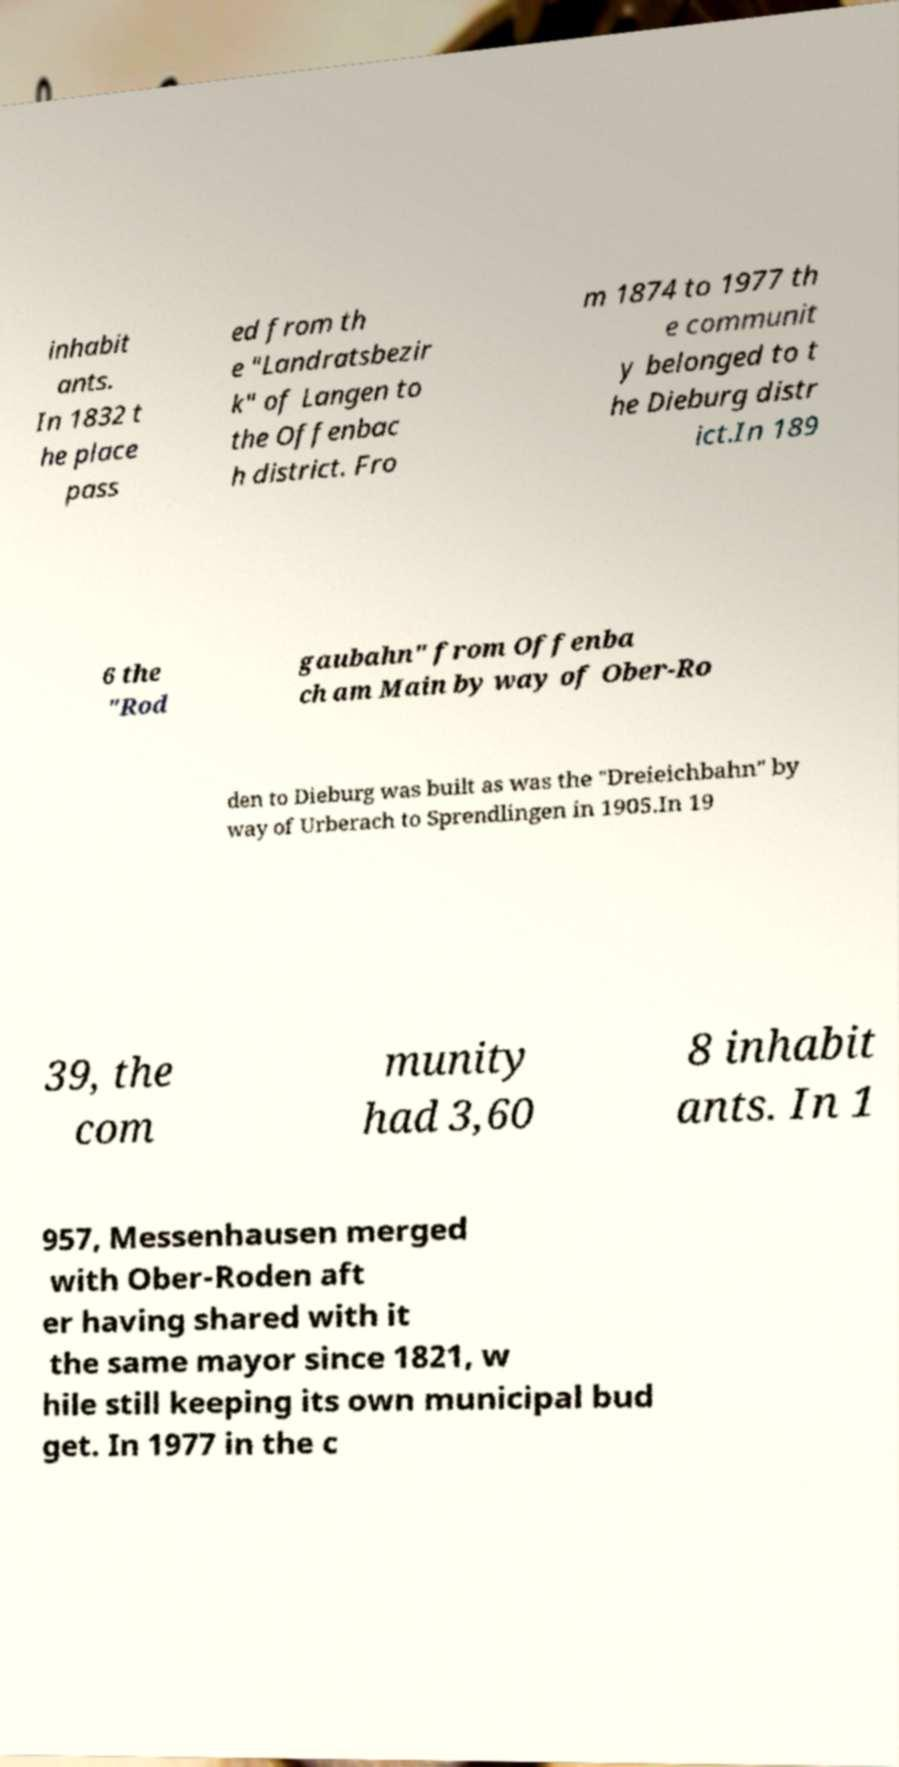There's text embedded in this image that I need extracted. Can you transcribe it verbatim? inhabit ants. In 1832 t he place pass ed from th e "Landratsbezir k" of Langen to the Offenbac h district. Fro m 1874 to 1977 th e communit y belonged to t he Dieburg distr ict.In 189 6 the "Rod gaubahn" from Offenba ch am Main by way of Ober-Ro den to Dieburg was built as was the "Dreieichbahn" by way of Urberach to Sprendlingen in 1905.In 19 39, the com munity had 3,60 8 inhabit ants. In 1 957, Messenhausen merged with Ober-Roden aft er having shared with it the same mayor since 1821, w hile still keeping its own municipal bud get. In 1977 in the c 